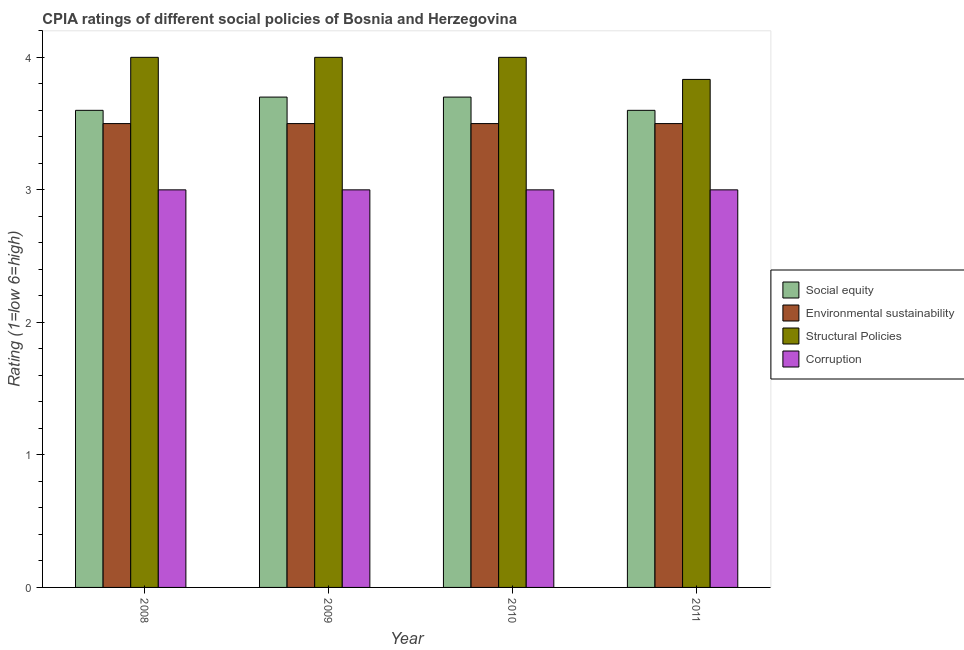How many different coloured bars are there?
Provide a short and direct response. 4. Are the number of bars per tick equal to the number of legend labels?
Offer a terse response. Yes. How many bars are there on the 3rd tick from the right?
Make the answer very short. 4. What is the label of the 3rd group of bars from the left?
Make the answer very short. 2010. In how many cases, is the number of bars for a given year not equal to the number of legend labels?
Your response must be concise. 0. What is the cpia rating of structural policies in 2009?
Offer a very short reply. 4. What is the total cpia rating of corruption in the graph?
Offer a very short reply. 12. What is the difference between the cpia rating of structural policies in 2008 and that in 2009?
Your answer should be very brief. 0. What is the difference between the cpia rating of social equity in 2009 and the cpia rating of corruption in 2010?
Your answer should be very brief. 0. What is the ratio of the cpia rating of social equity in 2009 to that in 2010?
Offer a very short reply. 1. Is the cpia rating of structural policies in 2008 less than that in 2010?
Offer a terse response. No. What is the difference between the highest and the second highest cpia rating of corruption?
Give a very brief answer. 0. What is the difference between the highest and the lowest cpia rating of social equity?
Ensure brevity in your answer.  0.1. In how many years, is the cpia rating of structural policies greater than the average cpia rating of structural policies taken over all years?
Make the answer very short. 3. Is it the case that in every year, the sum of the cpia rating of social equity and cpia rating of structural policies is greater than the sum of cpia rating of corruption and cpia rating of environmental sustainability?
Provide a succinct answer. No. What does the 1st bar from the left in 2010 represents?
Keep it short and to the point. Social equity. What does the 2nd bar from the right in 2011 represents?
Make the answer very short. Structural Policies. Is it the case that in every year, the sum of the cpia rating of social equity and cpia rating of environmental sustainability is greater than the cpia rating of structural policies?
Ensure brevity in your answer.  Yes. How many bars are there?
Offer a terse response. 16. How many years are there in the graph?
Make the answer very short. 4. Are the values on the major ticks of Y-axis written in scientific E-notation?
Make the answer very short. No. Does the graph contain grids?
Give a very brief answer. No. Where does the legend appear in the graph?
Offer a very short reply. Center right. How many legend labels are there?
Your answer should be compact. 4. How are the legend labels stacked?
Provide a succinct answer. Vertical. What is the title of the graph?
Offer a very short reply. CPIA ratings of different social policies of Bosnia and Herzegovina. Does "France" appear as one of the legend labels in the graph?
Your answer should be very brief. No. What is the label or title of the X-axis?
Your response must be concise. Year. What is the label or title of the Y-axis?
Ensure brevity in your answer.  Rating (1=low 6=high). What is the Rating (1=low 6=high) of Social equity in 2008?
Give a very brief answer. 3.6. What is the Rating (1=low 6=high) of Structural Policies in 2008?
Your response must be concise. 4. What is the Rating (1=low 6=high) of Corruption in 2008?
Provide a short and direct response. 3. What is the Rating (1=low 6=high) in Social equity in 2009?
Provide a short and direct response. 3.7. What is the Rating (1=low 6=high) of Structural Policies in 2009?
Provide a succinct answer. 4. What is the Rating (1=low 6=high) of Corruption in 2009?
Your answer should be compact. 3. What is the Rating (1=low 6=high) of Environmental sustainability in 2010?
Your answer should be very brief. 3.5. What is the Rating (1=low 6=high) of Structural Policies in 2010?
Your response must be concise. 4. What is the Rating (1=low 6=high) in Social equity in 2011?
Your answer should be very brief. 3.6. What is the Rating (1=low 6=high) in Structural Policies in 2011?
Your answer should be compact. 3.83. Across all years, what is the maximum Rating (1=low 6=high) of Social equity?
Give a very brief answer. 3.7. Across all years, what is the maximum Rating (1=low 6=high) of Structural Policies?
Give a very brief answer. 4. Across all years, what is the maximum Rating (1=low 6=high) of Corruption?
Your answer should be compact. 3. Across all years, what is the minimum Rating (1=low 6=high) in Social equity?
Keep it short and to the point. 3.6. Across all years, what is the minimum Rating (1=low 6=high) in Environmental sustainability?
Offer a very short reply. 3.5. Across all years, what is the minimum Rating (1=low 6=high) in Structural Policies?
Your answer should be compact. 3.83. Across all years, what is the minimum Rating (1=low 6=high) of Corruption?
Provide a short and direct response. 3. What is the total Rating (1=low 6=high) of Environmental sustainability in the graph?
Ensure brevity in your answer.  14. What is the total Rating (1=low 6=high) of Structural Policies in the graph?
Offer a very short reply. 15.83. What is the difference between the Rating (1=low 6=high) in Environmental sustainability in 2008 and that in 2010?
Your response must be concise. 0. What is the difference between the Rating (1=low 6=high) of Social equity in 2008 and that in 2011?
Your answer should be very brief. 0. What is the difference between the Rating (1=low 6=high) in Environmental sustainability in 2008 and that in 2011?
Your answer should be very brief. 0. What is the difference between the Rating (1=low 6=high) of Structural Policies in 2008 and that in 2011?
Provide a succinct answer. 0.17. What is the difference between the Rating (1=low 6=high) of Social equity in 2009 and that in 2010?
Your answer should be very brief. 0. What is the difference between the Rating (1=low 6=high) of Structural Policies in 2009 and that in 2010?
Make the answer very short. 0. What is the difference between the Rating (1=low 6=high) in Social equity in 2009 and that in 2011?
Offer a terse response. 0.1. What is the difference between the Rating (1=low 6=high) of Environmental sustainability in 2010 and that in 2011?
Provide a succinct answer. 0. What is the difference between the Rating (1=low 6=high) of Social equity in 2008 and the Rating (1=low 6=high) of Corruption in 2009?
Keep it short and to the point. 0.6. What is the difference between the Rating (1=low 6=high) in Environmental sustainability in 2008 and the Rating (1=low 6=high) in Corruption in 2009?
Keep it short and to the point. 0.5. What is the difference between the Rating (1=low 6=high) of Structural Policies in 2008 and the Rating (1=low 6=high) of Corruption in 2009?
Make the answer very short. 1. What is the difference between the Rating (1=low 6=high) of Social equity in 2008 and the Rating (1=low 6=high) of Corruption in 2010?
Your answer should be compact. 0.6. What is the difference between the Rating (1=low 6=high) in Structural Policies in 2008 and the Rating (1=low 6=high) in Corruption in 2010?
Provide a succinct answer. 1. What is the difference between the Rating (1=low 6=high) of Social equity in 2008 and the Rating (1=low 6=high) of Environmental sustainability in 2011?
Keep it short and to the point. 0.1. What is the difference between the Rating (1=low 6=high) in Social equity in 2008 and the Rating (1=low 6=high) in Structural Policies in 2011?
Offer a terse response. -0.23. What is the difference between the Rating (1=low 6=high) in Social equity in 2009 and the Rating (1=low 6=high) in Environmental sustainability in 2010?
Your response must be concise. 0.2. What is the difference between the Rating (1=low 6=high) in Social equity in 2009 and the Rating (1=low 6=high) in Structural Policies in 2010?
Your answer should be very brief. -0.3. What is the difference between the Rating (1=low 6=high) in Environmental sustainability in 2009 and the Rating (1=low 6=high) in Corruption in 2010?
Make the answer very short. 0.5. What is the difference between the Rating (1=low 6=high) of Social equity in 2009 and the Rating (1=low 6=high) of Environmental sustainability in 2011?
Offer a terse response. 0.2. What is the difference between the Rating (1=low 6=high) of Social equity in 2009 and the Rating (1=low 6=high) of Structural Policies in 2011?
Make the answer very short. -0.13. What is the difference between the Rating (1=low 6=high) in Social equity in 2009 and the Rating (1=low 6=high) in Corruption in 2011?
Ensure brevity in your answer.  0.7. What is the difference between the Rating (1=low 6=high) of Social equity in 2010 and the Rating (1=low 6=high) of Structural Policies in 2011?
Make the answer very short. -0.13. What is the difference between the Rating (1=low 6=high) in Structural Policies in 2010 and the Rating (1=low 6=high) in Corruption in 2011?
Ensure brevity in your answer.  1. What is the average Rating (1=low 6=high) in Social equity per year?
Make the answer very short. 3.65. What is the average Rating (1=low 6=high) of Environmental sustainability per year?
Make the answer very short. 3.5. What is the average Rating (1=low 6=high) of Structural Policies per year?
Offer a terse response. 3.96. What is the average Rating (1=low 6=high) of Corruption per year?
Your response must be concise. 3. In the year 2008, what is the difference between the Rating (1=low 6=high) in Social equity and Rating (1=low 6=high) in Environmental sustainability?
Provide a succinct answer. 0.1. In the year 2008, what is the difference between the Rating (1=low 6=high) in Social equity and Rating (1=low 6=high) in Structural Policies?
Your response must be concise. -0.4. In the year 2008, what is the difference between the Rating (1=low 6=high) in Social equity and Rating (1=low 6=high) in Corruption?
Give a very brief answer. 0.6. In the year 2008, what is the difference between the Rating (1=low 6=high) in Environmental sustainability and Rating (1=low 6=high) in Structural Policies?
Your answer should be compact. -0.5. In the year 2008, what is the difference between the Rating (1=low 6=high) in Structural Policies and Rating (1=low 6=high) in Corruption?
Provide a short and direct response. 1. In the year 2009, what is the difference between the Rating (1=low 6=high) of Environmental sustainability and Rating (1=low 6=high) of Corruption?
Make the answer very short. 0.5. In the year 2010, what is the difference between the Rating (1=low 6=high) in Social equity and Rating (1=low 6=high) in Environmental sustainability?
Offer a terse response. 0.2. In the year 2010, what is the difference between the Rating (1=low 6=high) of Social equity and Rating (1=low 6=high) of Corruption?
Your answer should be very brief. 0.7. In the year 2010, what is the difference between the Rating (1=low 6=high) of Environmental sustainability and Rating (1=low 6=high) of Structural Policies?
Provide a short and direct response. -0.5. In the year 2011, what is the difference between the Rating (1=low 6=high) of Social equity and Rating (1=low 6=high) of Environmental sustainability?
Keep it short and to the point. 0.1. In the year 2011, what is the difference between the Rating (1=low 6=high) in Social equity and Rating (1=low 6=high) in Structural Policies?
Make the answer very short. -0.23. In the year 2011, what is the difference between the Rating (1=low 6=high) of Structural Policies and Rating (1=low 6=high) of Corruption?
Offer a very short reply. 0.83. What is the ratio of the Rating (1=low 6=high) in Social equity in 2008 to that in 2009?
Offer a terse response. 0.97. What is the ratio of the Rating (1=low 6=high) of Corruption in 2008 to that in 2009?
Ensure brevity in your answer.  1. What is the ratio of the Rating (1=low 6=high) of Social equity in 2008 to that in 2010?
Offer a very short reply. 0.97. What is the ratio of the Rating (1=low 6=high) in Environmental sustainability in 2008 to that in 2011?
Your answer should be compact. 1. What is the ratio of the Rating (1=low 6=high) in Structural Policies in 2008 to that in 2011?
Your answer should be very brief. 1.04. What is the ratio of the Rating (1=low 6=high) in Corruption in 2008 to that in 2011?
Your answer should be very brief. 1. What is the ratio of the Rating (1=low 6=high) in Structural Policies in 2009 to that in 2010?
Provide a short and direct response. 1. What is the ratio of the Rating (1=low 6=high) of Social equity in 2009 to that in 2011?
Your answer should be very brief. 1.03. What is the ratio of the Rating (1=low 6=high) of Environmental sustainability in 2009 to that in 2011?
Give a very brief answer. 1. What is the ratio of the Rating (1=low 6=high) in Structural Policies in 2009 to that in 2011?
Give a very brief answer. 1.04. What is the ratio of the Rating (1=low 6=high) in Social equity in 2010 to that in 2011?
Keep it short and to the point. 1.03. What is the ratio of the Rating (1=low 6=high) in Environmental sustainability in 2010 to that in 2011?
Your response must be concise. 1. What is the ratio of the Rating (1=low 6=high) in Structural Policies in 2010 to that in 2011?
Your response must be concise. 1.04. What is the ratio of the Rating (1=low 6=high) in Corruption in 2010 to that in 2011?
Provide a succinct answer. 1. What is the difference between the highest and the second highest Rating (1=low 6=high) in Social equity?
Keep it short and to the point. 0. What is the difference between the highest and the second highest Rating (1=low 6=high) in Environmental sustainability?
Ensure brevity in your answer.  0. What is the difference between the highest and the second highest Rating (1=low 6=high) of Structural Policies?
Your response must be concise. 0. What is the difference between the highest and the second highest Rating (1=low 6=high) of Corruption?
Ensure brevity in your answer.  0. What is the difference between the highest and the lowest Rating (1=low 6=high) in Social equity?
Offer a very short reply. 0.1. What is the difference between the highest and the lowest Rating (1=low 6=high) of Environmental sustainability?
Ensure brevity in your answer.  0. What is the difference between the highest and the lowest Rating (1=low 6=high) in Structural Policies?
Offer a very short reply. 0.17. 